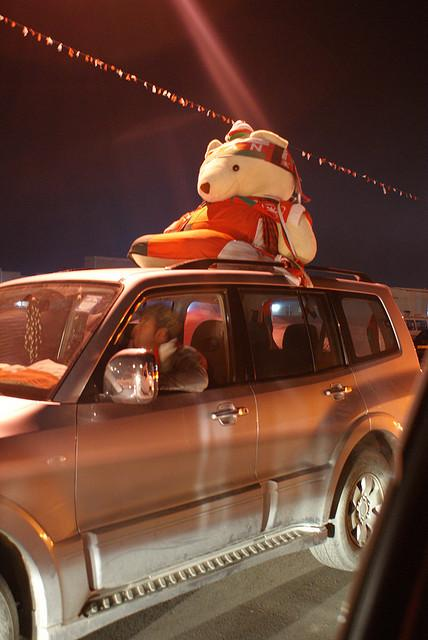What country is the scene located at? united states 